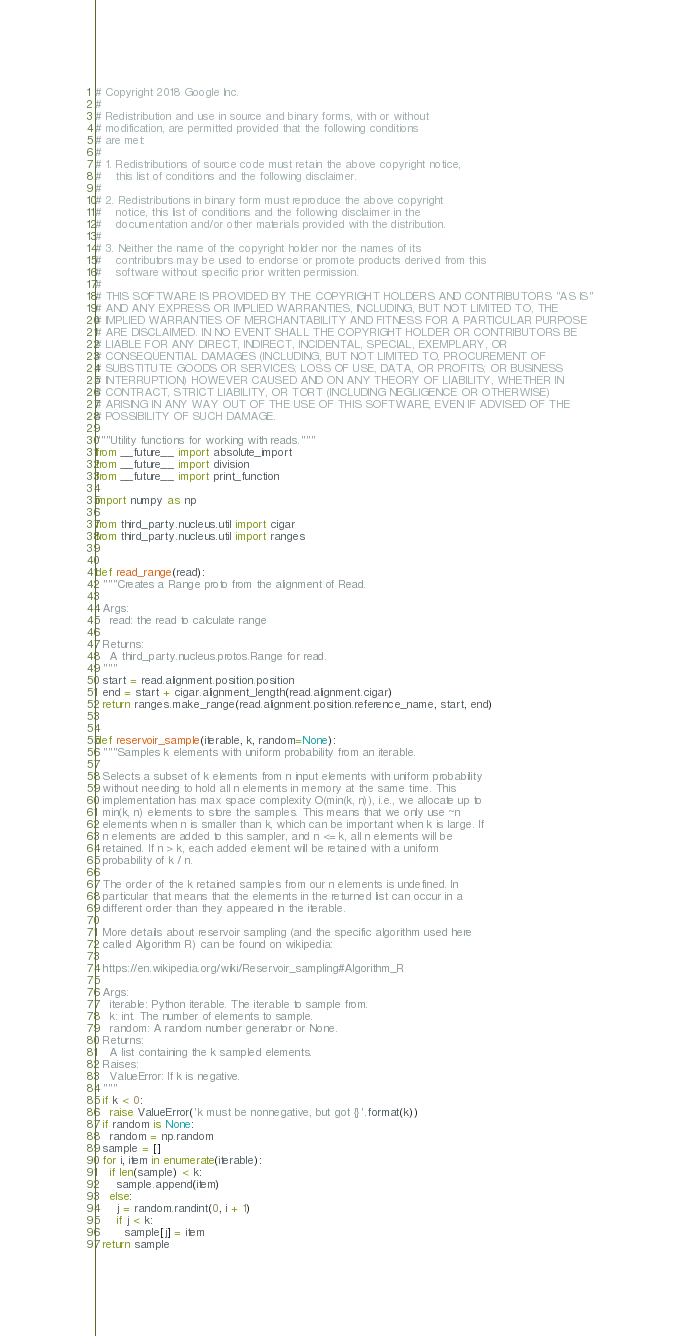<code> <loc_0><loc_0><loc_500><loc_500><_Python_># Copyright 2018 Google Inc.
#
# Redistribution and use in source and binary forms, with or without
# modification, are permitted provided that the following conditions
# are met:
#
# 1. Redistributions of source code must retain the above copyright notice,
#    this list of conditions and the following disclaimer.
#
# 2. Redistributions in binary form must reproduce the above copyright
#    notice, this list of conditions and the following disclaimer in the
#    documentation and/or other materials provided with the distribution.
#
# 3. Neither the name of the copyright holder nor the names of its
#    contributors may be used to endorse or promote products derived from this
#    software without specific prior written permission.
#
# THIS SOFTWARE IS PROVIDED BY THE COPYRIGHT HOLDERS AND CONTRIBUTORS "AS IS"
# AND ANY EXPRESS OR IMPLIED WARRANTIES, INCLUDING, BUT NOT LIMITED TO, THE
# IMPLIED WARRANTIES OF MERCHANTABILITY AND FITNESS FOR A PARTICULAR PURPOSE
# ARE DISCLAIMED. IN NO EVENT SHALL THE COPYRIGHT HOLDER OR CONTRIBUTORS BE
# LIABLE FOR ANY DIRECT, INDIRECT, INCIDENTAL, SPECIAL, EXEMPLARY, OR
# CONSEQUENTIAL DAMAGES (INCLUDING, BUT NOT LIMITED TO, PROCUREMENT OF
# SUBSTITUTE GOODS OR SERVICES; LOSS OF USE, DATA, OR PROFITS; OR BUSINESS
# INTERRUPTION) HOWEVER CAUSED AND ON ANY THEORY OF LIABILITY, WHETHER IN
# CONTRACT, STRICT LIABILITY, OR TORT (INCLUDING NEGLIGENCE OR OTHERWISE)
# ARISING IN ANY WAY OUT OF THE USE OF THIS SOFTWARE, EVEN IF ADVISED OF THE
# POSSIBILITY OF SUCH DAMAGE.

"""Utility functions for working with reads."""
from __future__ import absolute_import
from __future__ import division
from __future__ import print_function

import numpy as np

from third_party.nucleus.util import cigar
from third_party.nucleus.util import ranges


def read_range(read):
  """Creates a Range proto from the alignment of Read.

  Args:
    read: the read to calculate range

  Returns:
    A third_party.nucleus.protos.Range for read.
  """
  start = read.alignment.position.position
  end = start + cigar.alignment_length(read.alignment.cigar)
  return ranges.make_range(read.alignment.position.reference_name, start, end)


def reservoir_sample(iterable, k, random=None):
  """Samples k elements with uniform probability from an iterable.

  Selects a subset of k elements from n input elements with uniform probability
  without needing to hold all n elements in memory at the same time. This
  implementation has max space complexity O(min(k, n)), i.e., we allocate up to
  min(k, n) elements to store the samples. This means that we only use ~n
  elements when n is smaller than k, which can be important when k is large. If
  n elements are added to this sampler, and n <= k, all n elements will be
  retained. If n > k, each added element will be retained with a uniform
  probability of k / n.

  The order of the k retained samples from our n elements is undefined. In
  particular that means that the elements in the returned list can occur in a
  different order than they appeared in the iterable.

  More details about reservoir sampling (and the specific algorithm used here
  called Algorithm R) can be found on wikipedia:

  https://en.wikipedia.org/wiki/Reservoir_sampling#Algorithm_R

  Args:
    iterable: Python iterable. The iterable to sample from.
    k: int. The number of elements to sample.
    random: A random number generator or None.
  Returns:
    A list containing the k sampled elements.
  Raises:
    ValueError: If k is negative.
  """
  if k < 0:
    raise ValueError('k must be nonnegative, but got {}'.format(k))
  if random is None:
    random = np.random
  sample = []
  for i, item in enumerate(iterable):
    if len(sample) < k:
      sample.append(item)
    else:
      j = random.randint(0, i + 1)
      if j < k:
        sample[j] = item
  return sample
</code> 